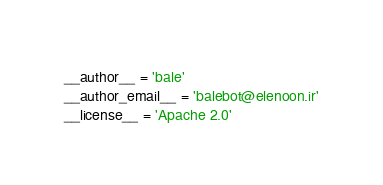Convert code to text. <code><loc_0><loc_0><loc_500><loc_500><_Python_>__author__ = 'bale'
__author_email__ = 'balebot@elenoon.ir'
__license__ = 'Apache 2.0'
</code> 